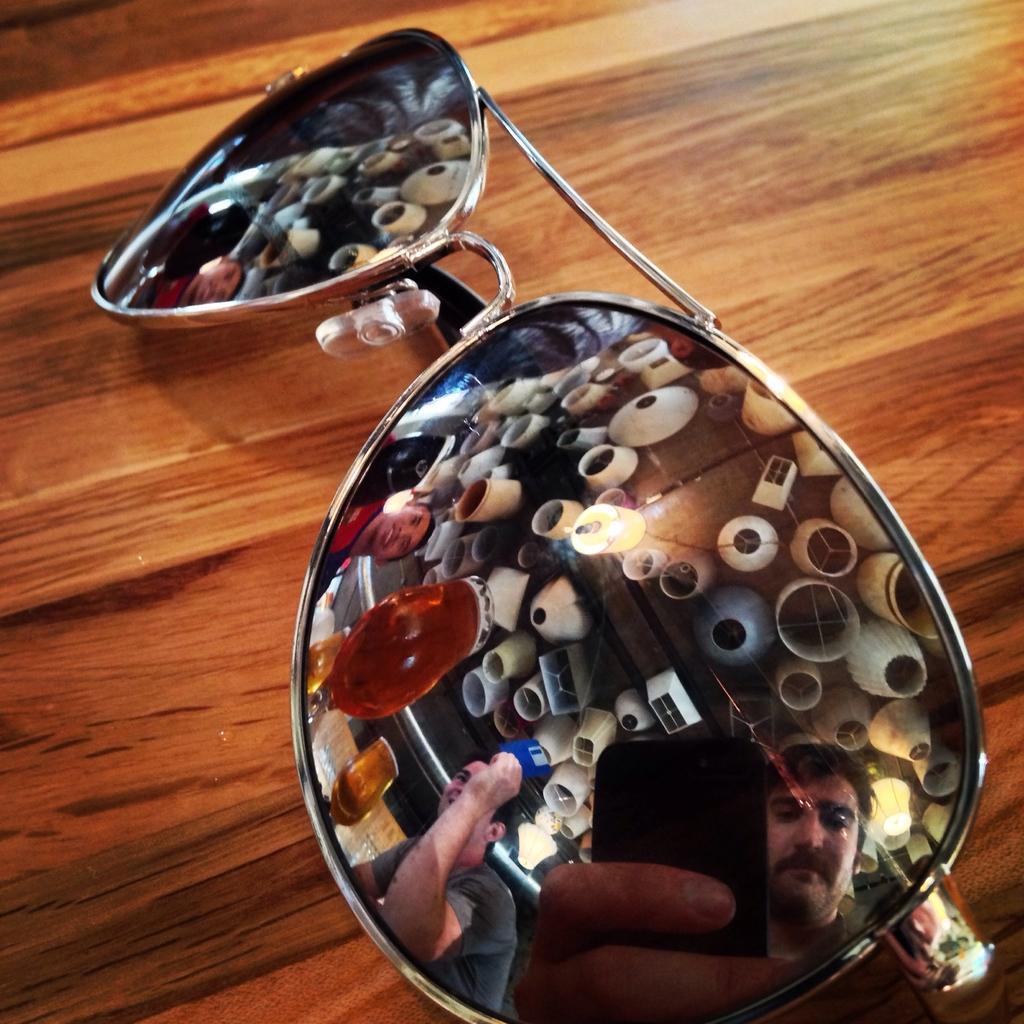Could you give a brief overview of what you see in this image? In this image I can see goggles which are placed on the table. On the glass I can see a person is holding a mobile in hand. Beside him there are two more men and I can see three wine glasses and white color balloons. 